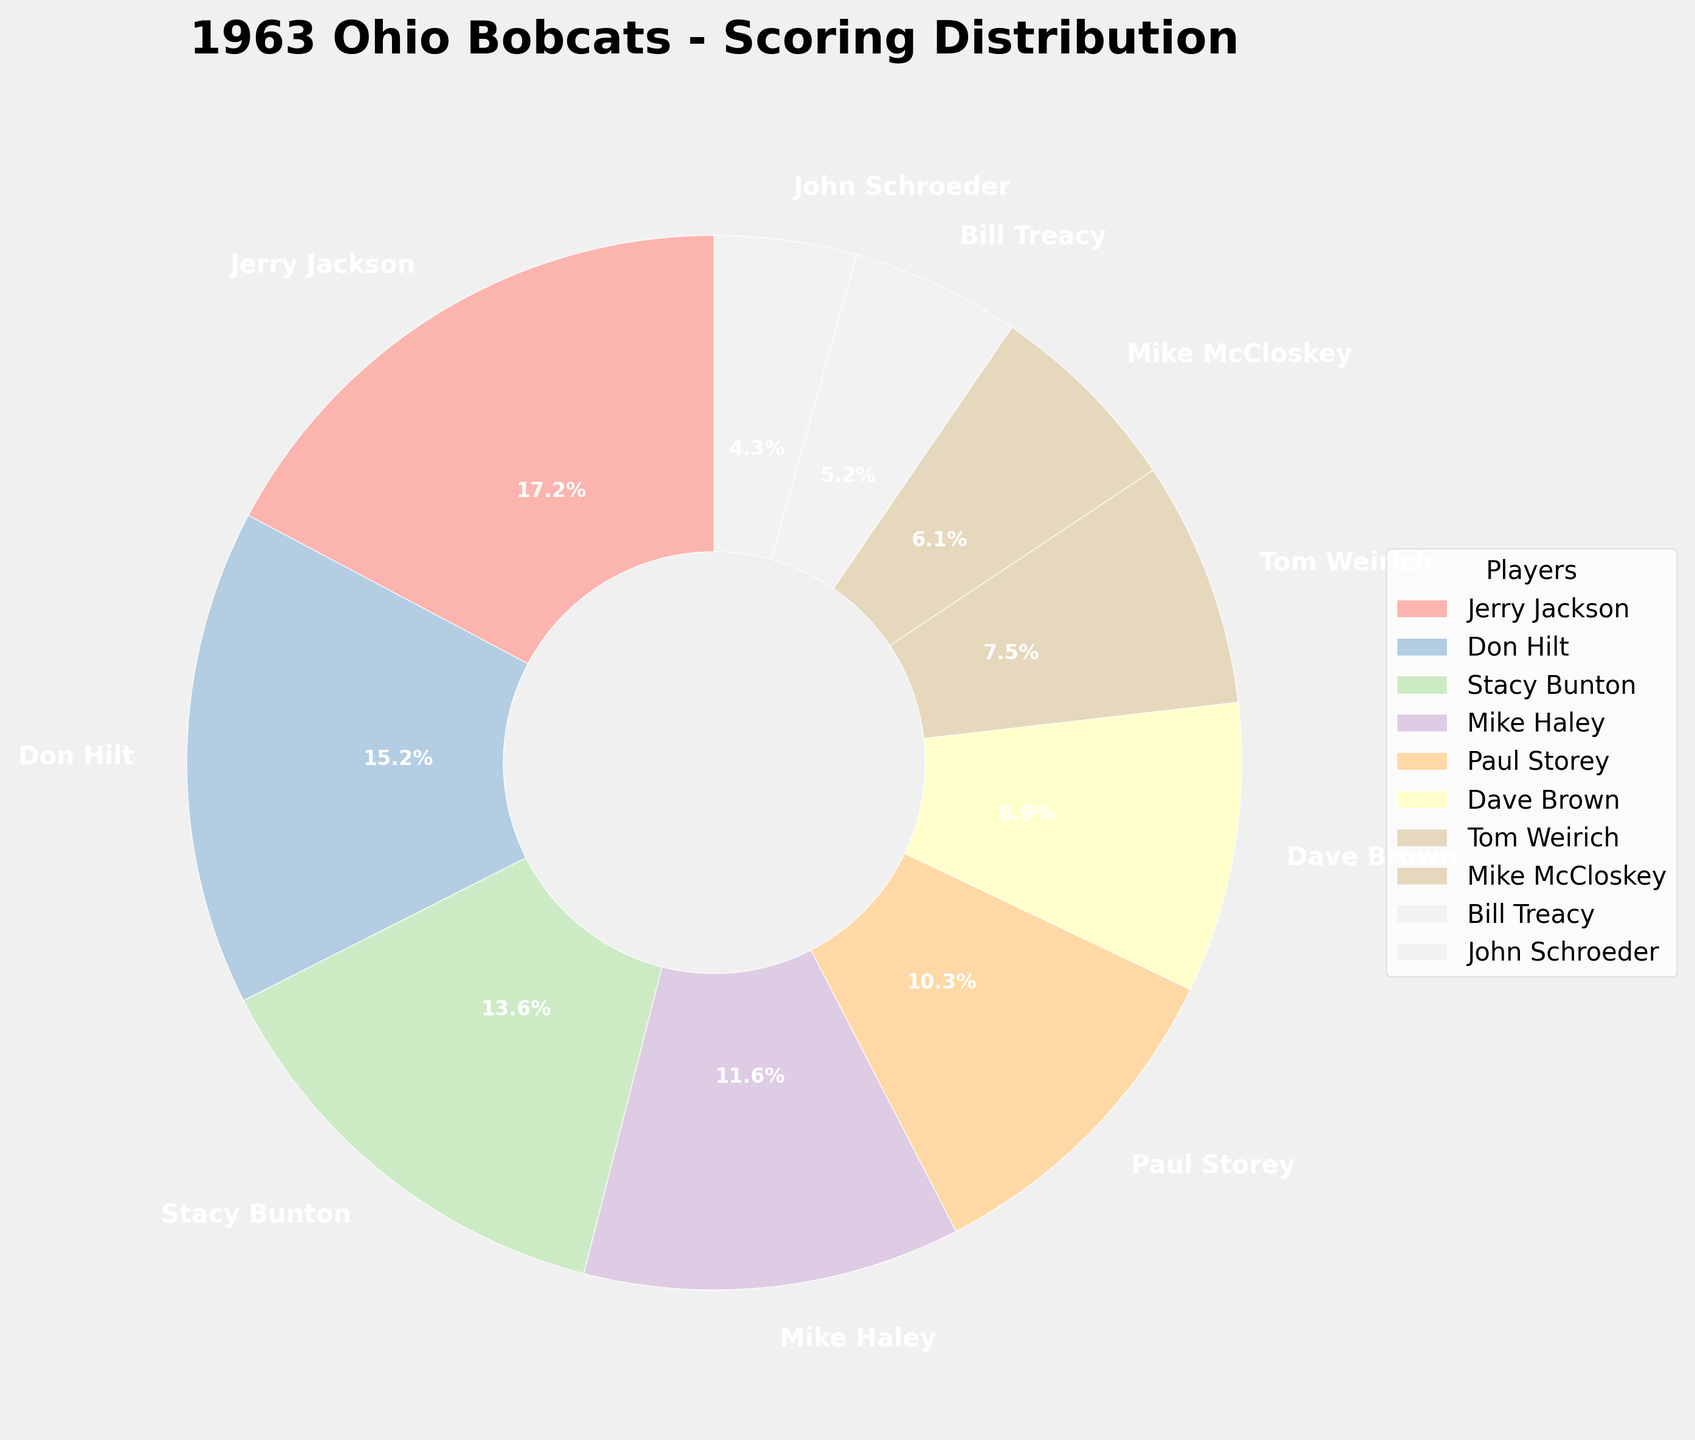Who scored the most points? The player with the largest segment of the pie chart represents the highest scorer. Jerry Jackson's segment is the largest.
Answer: Jerry Jackson Who scored the fewest points? The smallest segment of the pie chart indicates the player with the least points. John Schroeder's segment is the smallest.
Answer: John Schroeder What percentage of the total points did Don Hilt contribute? Each segment of the pie chart is labeled with the contribution percentage. Don Hilt's segment is labeled as 25.4%.
Answer: 25.4% How many players scored more than 200 points? Identify the players with segments larger than those labeled above 200 points. Jerry Jackson, Don Hilt, Stacy Bunton, Mike Haley, and Paul Storey scored more than 200 points. 5 players in total.
Answer: 5 Whose contribution was closest to 15%? Check the labels on the pie chart to find the percentage closest to 15%. Stacy Bunton's segment is closest with 15.3%.
Answer: Stacy Bunton What is the combined percentage contribution of Tom Weirich and Mike McCloskey? Sum the percentages labeled for Tom Weirich and Mike McCloskey. Tom Weirich (11.3%) + Mike McCloskey (9.2%) = 20.5%.
Answer: 20.5% Who are the three top scorers? Identify the largest three segments of the pie chart. The largest segments belong to Jerry Jackson, Don Hilt, and Stacy Bunton.
Answer: Jerry Jackson, Don Hilt, Stacy Bunton Does Jerry Jackson's contribution outweigh the combined contributions of Mike McCloskey and Bill Treacy? Compare the percentage of Jerry Jackson's segment with the sum of percentages for Mike McCloskey and Bill Treacy. Jerry Jackson's segment is larger (28.8%) than the combined percentage of Mike McCloskey (9.2%) and Bill Treacy (8.7%), which is 17.9%.
Answer: Yes Which player contributed approximately 19.4% of the points? Check the pie chart for the segment labeled with a contribution around 19.4%. Mike Haley's segment is labeled as 19.4%.
Answer: Mike Haley 